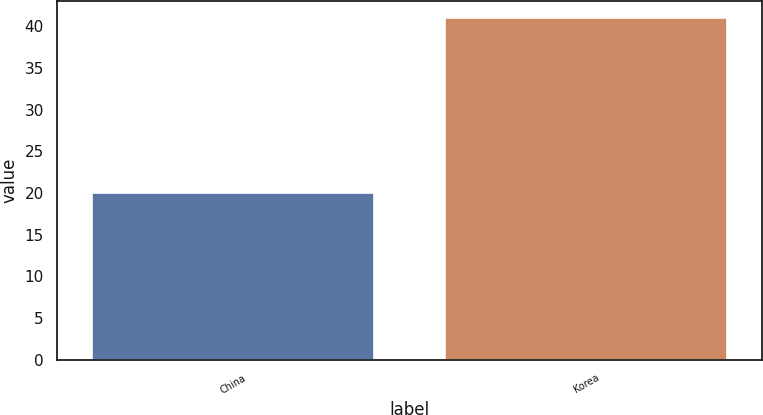Convert chart to OTSL. <chart><loc_0><loc_0><loc_500><loc_500><bar_chart><fcel>China<fcel>Korea<nl><fcel>20<fcel>41<nl></chart> 